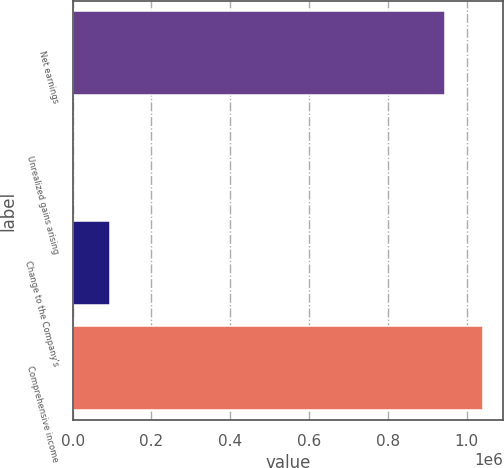Convert chart to OTSL. <chart><loc_0><loc_0><loc_500><loc_500><bar_chart><fcel>Net earnings<fcel>Unrealized gains arising<fcel>Change to the Company's<fcel>Comprehensive income<nl><fcel>945619<fcel>53<fcel>95249.7<fcel>1.04082e+06<nl></chart> 